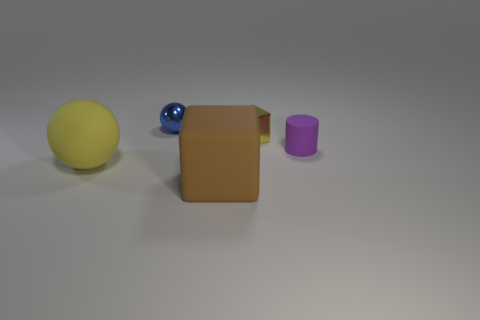There is another thing that is the same shape as the blue object; what is its color?
Offer a terse response. Yellow. Are the yellow object that is left of the big brown thing and the blue thing made of the same material?
Offer a terse response. No. How many tiny objects are either rubber blocks or blue objects?
Your answer should be compact. 1. The rubber block is what size?
Your answer should be very brief. Large. There is a blue thing; is its size the same as the yellow object left of the blue ball?
Your answer should be compact. No. How many yellow objects are either small spheres or cylinders?
Offer a terse response. 0. How many brown balls are there?
Offer a terse response. 0. What size is the yellow object in front of the rubber cylinder?
Your answer should be compact. Large. Is the yellow sphere the same size as the metallic cube?
Make the answer very short. No. How many objects are either yellow cubes or small shiny things that are to the left of the tiny yellow block?
Offer a very short reply. 2. 